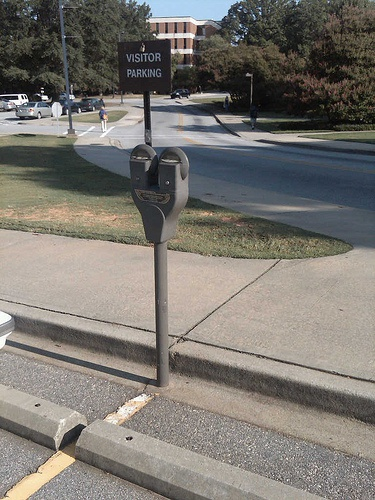Describe the objects in this image and their specific colors. I can see parking meter in gray and black tones, car in gray, darkgray, lightgray, and black tones, car in gray, black, and darkgray tones, car in gray, black, blue, and darkblue tones, and car in gray, black, and darkgray tones in this image. 